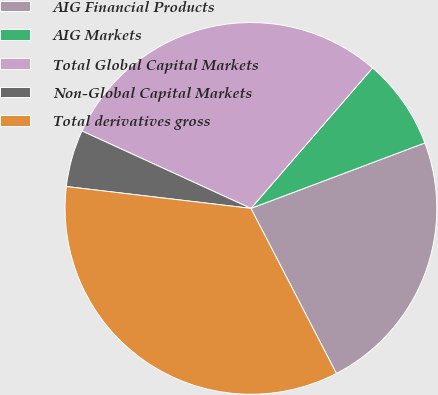Convert chart. <chart><loc_0><loc_0><loc_500><loc_500><pie_chart><fcel>AIG Financial Products<fcel>AIG Markets<fcel>Total Global Capital Markets<fcel>Non-Global Capital Markets<fcel>Total derivatives gross<nl><fcel>23.12%<fcel>7.91%<fcel>29.52%<fcel>4.96%<fcel>34.48%<nl></chart> 